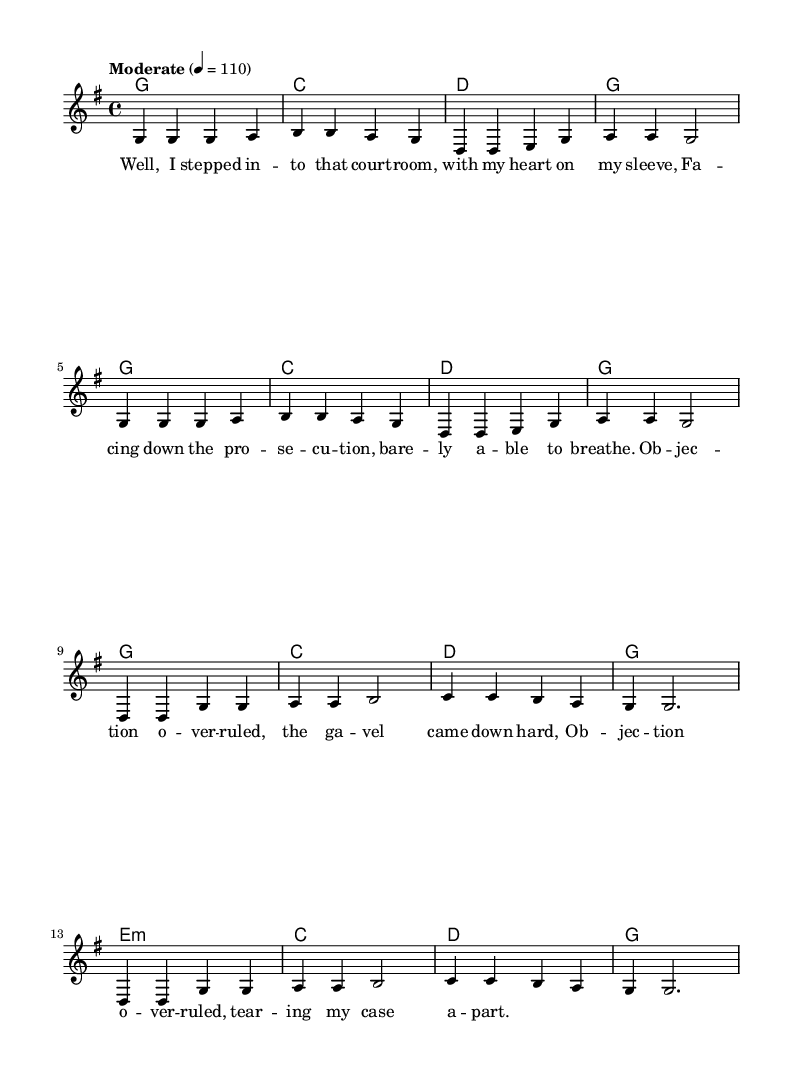What is the key signature of this music? The key signature is G major, which has one sharp (F#). This can be determined from the 'key g \major' mentioned at the beginning of the staff.
Answer: G major What is the time signature of this music? The time signature is 4/4, which is indicated by '\time 4/4' in the score. This means there are four beats per measure, and the quarter note gets one beat.
Answer: 4/4 What is the tempo marking given in this music? The tempo marking is "Moderate," which indicates a moderate pace for the performance. This is noted at the start of the score with 'tempo "Moderate" 4 = 110', meaning the quarter note should pulse at 110 beats per minute.
Answer: Moderate What chord is played in the second measure? The second measure features the chord B, which can be deduced from the chord names provided in the 'ChordNames' section at the beginning of the score.
Answer: B What is the last lyric sung in the chorus? The last lyric sung in the chorus is "g g2.", which corresponds to the final musical notation in that section and indicates the conclusion of the chorus line.
Answer: g g2 What is the first note of the verse? The first note of the verse is G, as seen in the very first measure and indicated by the notation 'g4' at the start of the verse.
Answer: G 